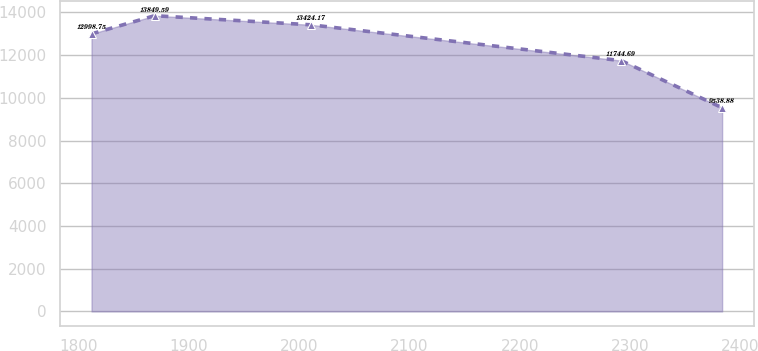Convert chart to OTSL. <chart><loc_0><loc_0><loc_500><loc_500><line_chart><ecel><fcel>Unnamed: 1<nl><fcel>1811.62<fcel>12998.8<nl><fcel>1868.79<fcel>13849.6<nl><fcel>2010.24<fcel>13424.2<nl><fcel>2291.87<fcel>11744.7<nl><fcel>2383.32<fcel>9538.88<nl></chart> 